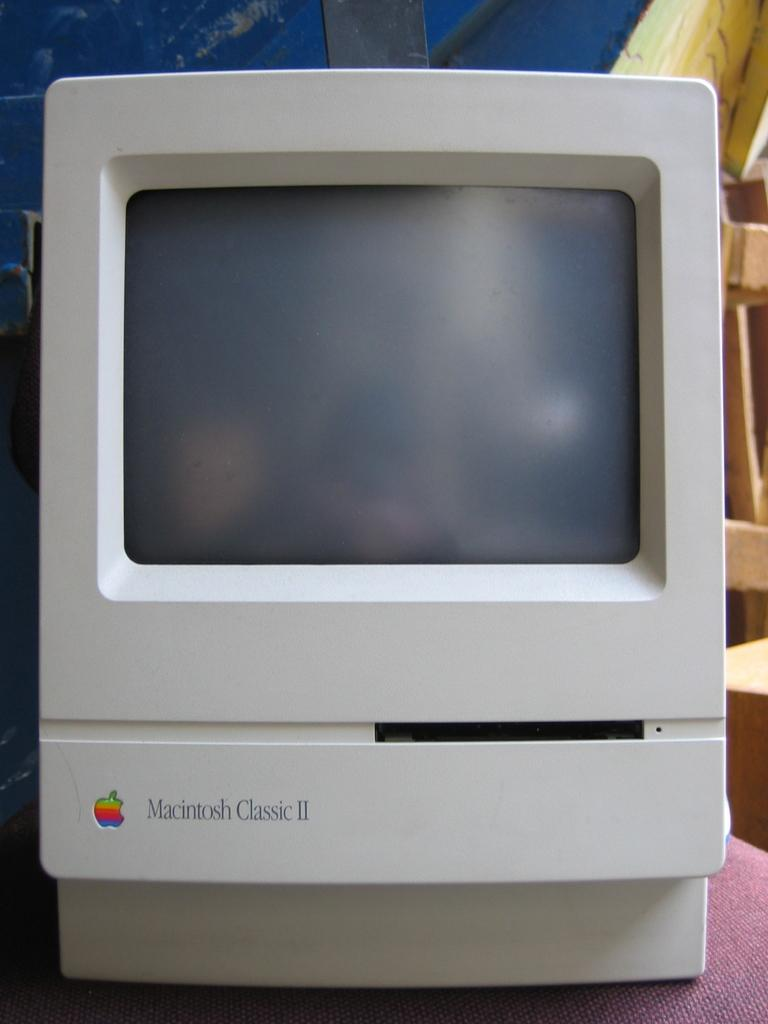<image>
Describe the image concisely. A fairly clean looking macintosh classic II fills the frame. 